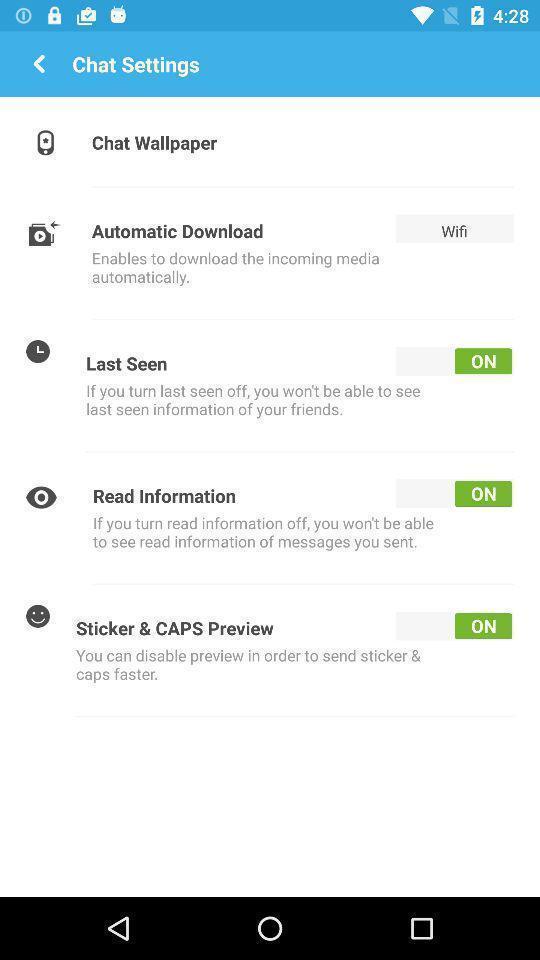Please provide a description for this image. Settings page. 